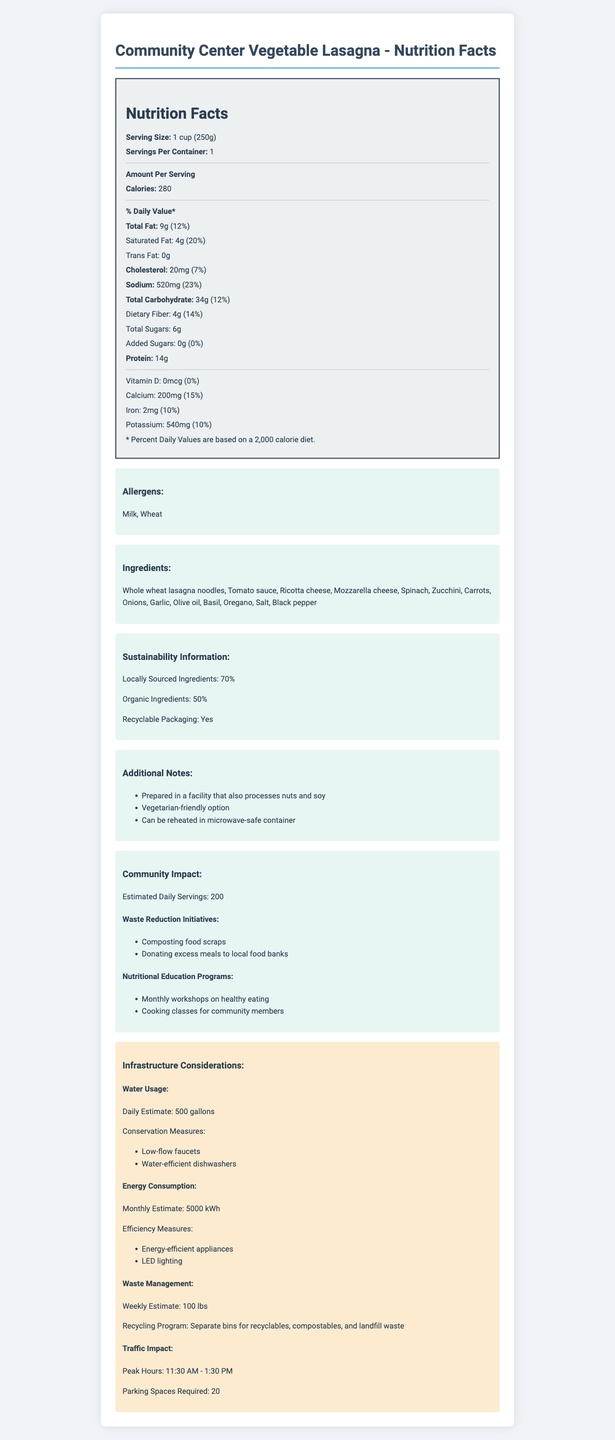what is the serving size for the Community Center Vegetable Lasagna? The serving size is explicitly mentioned at the top of the Nutrition Facts section as "Serving Size: 1 cup (250g)".
Answer: 1 cup (250g) how many calories are in one serving? The calories content for one serving is listed directly under the "Amount Per Serving" section: "Calories: 280".
Answer: 280 calories what percentage of daily value of sodium does one serving provide? The document states "Sodium: 520mg (23%)" detailing the amount and daily value percentage.
Answer: 23% how much dietary fiber is in one serving, and what is its daily value percentage? The dietary fiber content is "Dietary Fiber: 4g (14%)", as listed under Total Carbohydrate.
Answer: 4g, 14% what allergens are present in the Vegetable Lasagna? The allergens section specifies "Allergens: Milk, Wheat".
Answer: Milk, Wheat The total fat content in the lasagna is: A. 9g B. 12g C. 7g D. 15g The document indicates "Total Fat: 9g (12%)", clearly showing the amount of total fat.
Answer: A. 9g What part of the lasagna's packaging is mentioned regarding sustainability? I. Biodegradable II. Compostable III. Recyclable IV. None The sustainability information includes "Recyclable Packaging: Yes".
Answer: III. Recyclable Does the document mention any waste management initiatives? The community impact section specifically details waste reduction initiatives like "Composting food scraps" and "Donating excess meals to local food banks".
Answer: Yes Is the Vegetable Lasagna suitable for vegetarians? One of the additional notes highlights "Vegetarian-friendly option".
Answer: Yes Summarize the main idea of the document. The document gives a full overview of the nutritional facts, ingredient details, and sustainability aspects of the Vegetable Lasagna served at the Community Center cafeteria. It also highlights the community programs and infrastructural impacts associated with the cafeteria's operation.
Answer: The document provides comprehensive details on the nutritional content of the Community Center Vegetable Lasagna, including serving size, calories, fat, sodium, and other nutritional values. It mentions potential allergens, ingredients, sustainability initiatives, and community impact information. Additionally, it considers infrastructure aspects like water, energy usage, waste management, and traffic. How much energy usage per day is expected at peak hours? The document provides a summary of monthly energy consumption, but does not detail specific energy usage during peak hours.
Answer: Not enough information For how many daily servings is the Community Center Vegetable Lasagna estimated? The "Community Impact" section states the "Estimated Daily Servings: 200".
Answer: 200 How much is the cholesterol content in one serving? The cholesterol content is listed under "Amount Per Serving" as "Cholesterol: 20mg (7%)".
Answer: 20mg Which ingredient is not used in the lasagna? A. Zucchini B. Eggplant C. Basil D. Ricotta cheese The ingredient list includes zucchini, basil, and ricotta cheese, but does not mention eggplant.
Answer: B. Eggplant 